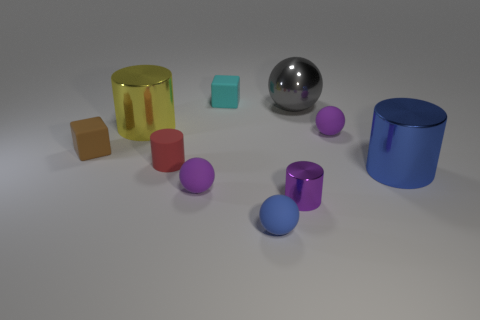There is a yellow metal thing; does it have the same shape as the small purple rubber thing that is behind the brown rubber object?
Your answer should be compact. No. How many other objects are the same material as the big blue cylinder?
Offer a very short reply. 3. The tiny rubber block in front of the tiny rubber sphere that is behind the big object that is in front of the red matte cylinder is what color?
Offer a terse response. Brown. There is a matte object that is behind the small ball that is behind the blue shiny thing; what is its shape?
Make the answer very short. Cube. Is the number of spheres in front of the cyan object greater than the number of small purple things?
Offer a very short reply. Yes. Do the purple object on the right side of the tiny purple metallic thing and the gray thing have the same shape?
Give a very brief answer. Yes. Are there any cyan matte things of the same shape as the gray metallic thing?
Offer a terse response. No. How many objects are either purple spheres behind the small red cylinder or large blue metal cylinders?
Ensure brevity in your answer.  2. Is the number of blue spheres greater than the number of tiny green blocks?
Offer a very short reply. Yes. Are there any yellow cylinders that have the same size as the gray shiny object?
Keep it short and to the point. Yes. 